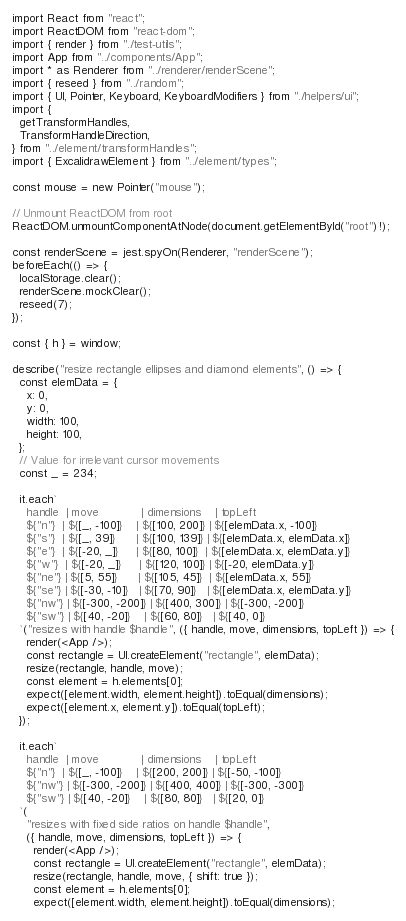Convert code to text. <code><loc_0><loc_0><loc_500><loc_500><_TypeScript_>import React from "react";
import ReactDOM from "react-dom";
import { render } from "./test-utils";
import App from "../components/App";
import * as Renderer from "../renderer/renderScene";
import { reseed } from "../random";
import { UI, Pointer, Keyboard, KeyboardModifiers } from "./helpers/ui";
import {
  getTransformHandles,
  TransformHandleDirection,
} from "../element/transformHandles";
import { ExcalidrawElement } from "../element/types";

const mouse = new Pointer("mouse");

// Unmount ReactDOM from root
ReactDOM.unmountComponentAtNode(document.getElementById("root")!);

const renderScene = jest.spyOn(Renderer, "renderScene");
beforeEach(() => {
  localStorage.clear();
  renderScene.mockClear();
  reseed(7);
});

const { h } = window;

describe("resize rectangle ellipses and diamond elements", () => {
  const elemData = {
    x: 0,
    y: 0,
    width: 100,
    height: 100,
  };
  // Value for irrelevant cursor movements
  const _ = 234;

  it.each`
    handle  | move            | dimensions    | topLeft
    ${"n"}  | ${[_, -100]}    | ${[100, 200]} | ${[elemData.x, -100]}
    ${"s"}  | ${[_, 39]}      | ${[100, 139]} | ${[elemData.x, elemData.x]}
    ${"e"}  | ${[-20, _]}     | ${[80, 100]}  | ${[elemData.x, elemData.y]}
    ${"w"}  | ${[-20, _]}     | ${[120, 100]} | ${[-20, elemData.y]}
    ${"ne"} | ${[5, 55]}      | ${[105, 45]}  | ${[elemData.x, 55]}
    ${"se"} | ${[-30, -10]}   | ${[70, 90]}   | ${[elemData.x, elemData.y]}
    ${"nw"} | ${[-300, -200]} | ${[400, 300]} | ${[-300, -200]}
    ${"sw"} | ${[40, -20]}    | ${[60, 80]}   | ${[40, 0]}
  `("resizes with handle $handle", ({ handle, move, dimensions, topLeft }) => {
    render(<App />);
    const rectangle = UI.createElement("rectangle", elemData);
    resize(rectangle, handle, move);
    const element = h.elements[0];
    expect([element.width, element.height]).toEqual(dimensions);
    expect([element.x, element.y]).toEqual(topLeft);
  });

  it.each`
    handle  | move            | dimensions    | topLeft
    ${"n"}  | ${[_, -100]}    | ${[200, 200]} | ${[-50, -100]}
    ${"nw"} | ${[-300, -200]} | ${[400, 400]} | ${[-300, -300]}
    ${"sw"} | ${[40, -20]}    | ${[80, 80]}   | ${[20, 0]}
  `(
    "resizes with fixed side ratios on handle $handle",
    ({ handle, move, dimensions, topLeft }) => {
      render(<App />);
      const rectangle = UI.createElement("rectangle", elemData);
      resize(rectangle, handle, move, { shift: true });
      const element = h.elements[0];
      expect([element.width, element.height]).toEqual(dimensions);</code> 